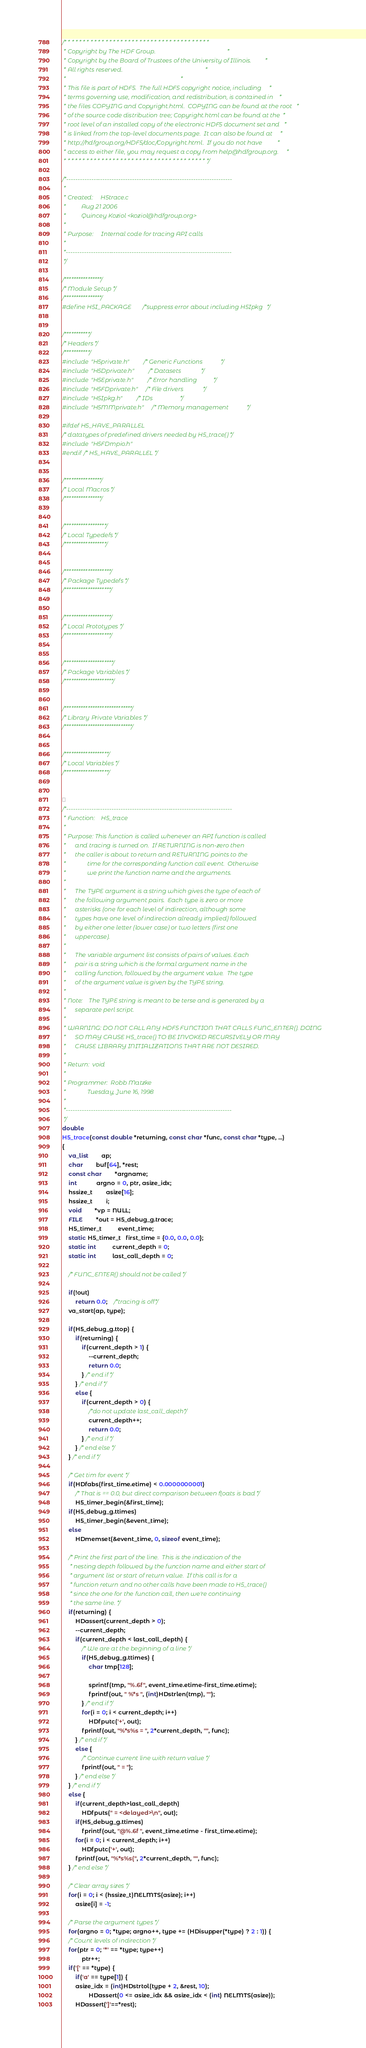Convert code to text. <code><loc_0><loc_0><loc_500><loc_500><_C_>/* * * * * * * * * * * * * * * * * * * * * * * * * * * * * * * * * * * * * * *
 * Copyright by The HDF Group.                                               *
 * Copyright by the Board of Trustees of the University of Illinois.         *
 * All rights reserved.                                                      *
 *                                                                           *
 * This file is part of HDF5.  The full HDF5 copyright notice, including     *
 * terms governing use, modification, and redistribution, is contained in    *
 * the files COPYING and Copyright.html.  COPYING can be found at the root   *
 * of the source code distribution tree; Copyright.html can be found at the  *
 * root level of an installed copy of the electronic HDF5 document set and   *
 * is linked from the top-level documents page.  It can also be found at     *
 * http://hdfgroup.org/HDF5/doc/Copyright.html.  If you do not have          *
 * access to either file, you may request a copy from help@hdfgroup.org.     *
 * * * * * * * * * * * * * * * * * * * * * * * * * * * * * * * * * * * * * * */

/*-------------------------------------------------------------------------
 *
 * Created:		H5trace.c
 *			Aug 21 2006
 *			Quincey Koziol <koziol@hdfgroup.org>
 *
 * Purpose:		Internal code for tracing API calls
 *
 *-------------------------------------------------------------------------
 */

/****************/
/* Module Setup */
/****************/
#define H5I_PACKAGE		/*suppress error about including H5Ipkg	  */


/***********/
/* Headers */
/***********/
#include "H5private.h"		/* Generic Functions			*/
#include "H5Dprivate.h"		/* Datasets				*/
#include "H5Eprivate.h"		/* Error handling		  	*/
#include "H5FDprivate.h"	/* File drivers				*/
#include "H5Ipkg.h"		/* IDs			  		*/
#include "H5MMprivate.h"	/* Memory management			*/

#ifdef H5_HAVE_PARALLEL
/* datatypes of predefined drivers needed by H5_trace() */
#include "H5FDmpio.h"
#endif /* H5_HAVE_PARALLEL */


/****************/
/* Local Macros */
/****************/


/******************/
/* Local Typedefs */
/******************/


/********************/
/* Package Typedefs */
/********************/


/********************/
/* Local Prototypes */
/********************/


/*********************/
/* Package Variables */
/*********************/


/*****************************/
/* Library Private Variables */
/*****************************/


/*******************/
/* Local Variables */
/*******************/



/*-------------------------------------------------------------------------
 * Function:	H5_trace
 *
 * Purpose:	This function is called whenever an API function is called
 *		and tracing is turned on.  If RETURNING is non-zero then
 *		the caller is about to return and RETURNING points to the
 *              time for the corresponding function call event.  Otherwise
 *              we print the function name and the arguments.
 *
 *		The TYPE argument is a string which gives the type of each of
 *		the following argument pairs.  Each type is zero or more
 *		asterisks (one for each level of indirection, although some
 *		types have one level of indirection already implied) followed
 *		by either one letter (lower case) or two letters (first one
 *		uppercase).
 *
 *		The variable argument list consists of pairs of values. Each
 *		pair is a string which is the formal argument name in the
 *		calling function, followed by the argument value.  The type
 *		of the argument value is given by the TYPE string.
 *
 * Note:	The TYPE string is meant to be terse and is generated by a
 *		separate perl script.
 *
 * WARNING:	DO NOT CALL ANY HDF5 FUNCTION THAT CALLS FUNC_ENTER(). DOING
 *		SO MAY CAUSE H5_trace() TO BE INVOKED RECURSIVELY OR MAY
 *		CAUSE LIBRARY INITIALIZATIONS THAT ARE NOT DESIRED.
 *
 * Return:	void
 *
 * Programmer:	Robb Matzke
 *              Tuesday, June 16, 1998
 *
 *-------------------------------------------------------------------------
 */
double
H5_trace(const double *returning, const char *func, const char *type, ...)
{
    va_list		ap;
    char		buf[64], *rest;
    const char		*argname;
    int			argno = 0, ptr, asize_idx;
    hssize_t		asize[16];
    hssize_t		i;
    void		*vp = NULL;
    FILE		*out = H5_debug_g.trace;
    H5_timer_t          event_time;
    static H5_timer_t   first_time = {0.0, 0.0, 0.0};
    static int          current_depth = 0;
    static int          last_call_depth = 0;

    /* FUNC_ENTER() should not be called */

    if(!out)
        return 0.0;	/*tracing is off*/
    va_start(ap, type);

    if(H5_debug_g.ttop) {
        if(returning) {
            if(current_depth > 1) {
                --current_depth;
                return 0.0;
            } /* end if */
        } /* end if */
        else {
            if(current_depth > 0) {
                /*do not update last_call_depth*/
                current_depth++;
                return 0.0;
            } /* end if */
        } /* end else */
    } /* end if */

    /* Get tim for event */
    if(HDfabs(first_time.etime) < 0.0000000001)
        /* That is == 0.0, but direct comparison between floats is bad */
        H5_timer_begin(&first_time);
    if(H5_debug_g.ttimes)
        H5_timer_begin(&event_time);
    else
        HDmemset(&event_time, 0, sizeof event_time);

    /* Print the first part of the line.  This is the indication of the
     * nesting depth followed by the function name and either start of
     * argument list or start of return value.  If this call is for a
     * function return and no other calls have been made to H5_trace()
     * since the one for the function call, then we're continuing
     * the same line. */
    if(returning) {
        HDassert(current_depth > 0);
        --current_depth;
        if(current_depth < last_call_depth) {
            /* We are at the beginning of a line */
            if(H5_debug_g.ttimes) {
                char tmp[128];

                sprintf(tmp, "%.6f", event_time.etime-first_time.etime);
                fprintf(out, " %*s ", (int)HDstrlen(tmp), "");
            } /* end if */
            for(i = 0; i < current_depth; i++)
                HDfputc('+', out);
            fprintf(out, "%*s%s = ", 2*current_depth, "", func);
        } /* end if */
        else {
            /* Continue current line with return value */
            fprintf(out, " = ");
        } /* end else */
    } /* end if */
    else {
        if(current_depth>last_call_depth)
            HDfputs(" = <delayed>\n", out);
        if(H5_debug_g.ttimes)
            fprintf(out, "@%.6f ", event_time.etime - first_time.etime);
        for(i = 0; i < current_depth; i++)
            HDfputc('+', out);
        fprintf(out, "%*s%s(", 2*current_depth, "", func);
    } /* end else */

    /* Clear array sizes */
    for(i = 0; i < (hssize_t)NELMTS(asize); i++)
        asize[i] = -1;

    /* Parse the argument types */
    for(argno = 0; *type; argno++, type += (HDisupper(*type) ? 2 : 1)) {
	/* Count levels of indirection */
	for(ptr = 0; '*' == *type; type++)
            ptr++;
	if('[' == *type) {
	    if('a' == type[1]) {
		asize_idx = (int)HDstrtol(type + 2, &rest, 10);
                HDassert(0 <= asize_idx && asize_idx < (int) NELMTS(asize));
		HDassert(']'==*rest);</code> 